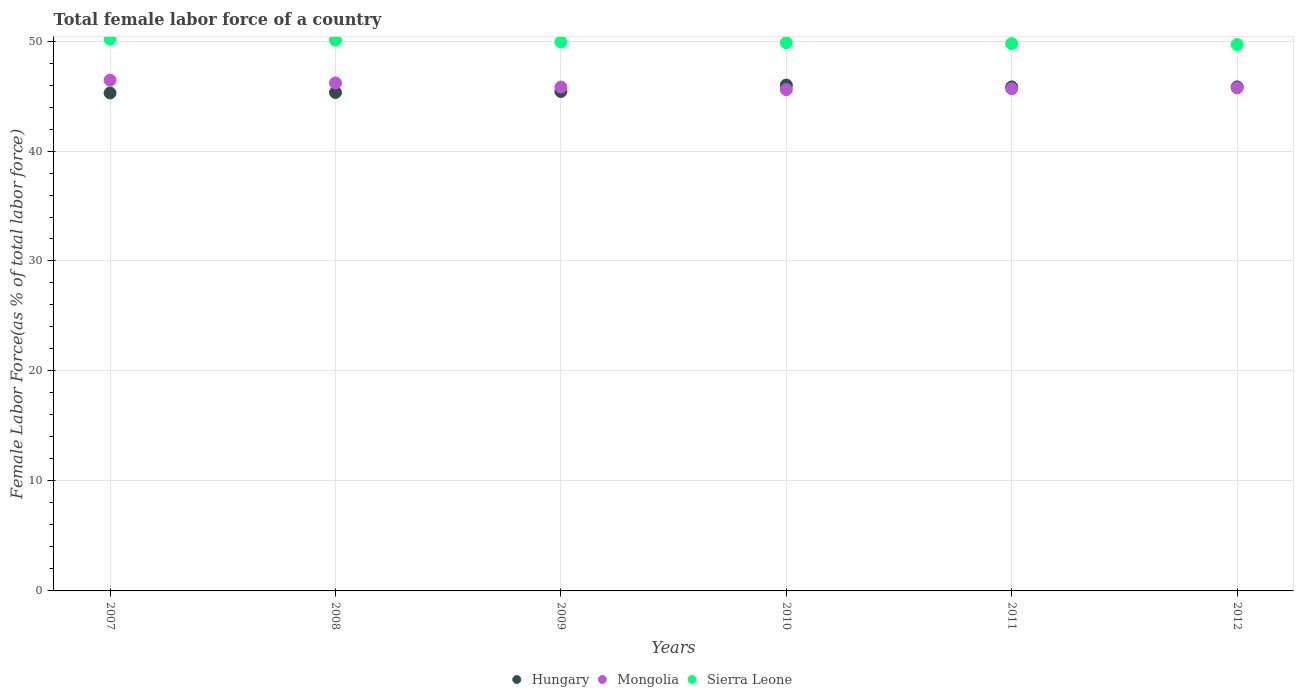How many different coloured dotlines are there?
Offer a very short reply. 3. Is the number of dotlines equal to the number of legend labels?
Provide a succinct answer. Yes. What is the percentage of female labor force in Sierra Leone in 2007?
Offer a very short reply. 50.16. Across all years, what is the maximum percentage of female labor force in Mongolia?
Your answer should be very brief. 46.44. Across all years, what is the minimum percentage of female labor force in Sierra Leone?
Your response must be concise. 49.68. What is the total percentage of female labor force in Hungary in the graph?
Offer a very short reply. 273.67. What is the difference between the percentage of female labor force in Mongolia in 2011 and that in 2012?
Make the answer very short. -0.08. What is the difference between the percentage of female labor force in Hungary in 2008 and the percentage of female labor force in Sierra Leone in 2010?
Provide a succinct answer. -4.52. What is the average percentage of female labor force in Sierra Leone per year?
Your answer should be compact. 49.91. In the year 2010, what is the difference between the percentage of female labor force in Sierra Leone and percentage of female labor force in Hungary?
Your response must be concise. 3.85. What is the ratio of the percentage of female labor force in Sierra Leone in 2011 to that in 2012?
Your answer should be very brief. 1. Is the difference between the percentage of female labor force in Sierra Leone in 2009 and 2012 greater than the difference between the percentage of female labor force in Hungary in 2009 and 2012?
Your response must be concise. Yes. What is the difference between the highest and the second highest percentage of female labor force in Sierra Leone?
Ensure brevity in your answer.  0.08. What is the difference between the highest and the lowest percentage of female labor force in Hungary?
Provide a short and direct response. 0.72. In how many years, is the percentage of female labor force in Sierra Leone greater than the average percentage of female labor force in Sierra Leone taken over all years?
Provide a succinct answer. 3. Is the sum of the percentage of female labor force in Sierra Leone in 2009 and 2010 greater than the maximum percentage of female labor force in Hungary across all years?
Your answer should be compact. Yes. Does the percentage of female labor force in Mongolia monotonically increase over the years?
Your answer should be compact. No. Is the percentage of female labor force in Sierra Leone strictly less than the percentage of female labor force in Hungary over the years?
Provide a succinct answer. No. How many years are there in the graph?
Make the answer very short. 6. Are the values on the major ticks of Y-axis written in scientific E-notation?
Give a very brief answer. No. Does the graph contain any zero values?
Your answer should be very brief. No. How are the legend labels stacked?
Provide a succinct answer. Horizontal. What is the title of the graph?
Provide a succinct answer. Total female labor force of a country. What is the label or title of the X-axis?
Make the answer very short. Years. What is the label or title of the Y-axis?
Provide a succinct answer. Female Labor Force(as % of total labor force). What is the Female Labor Force(as % of total labor force) in Hungary in 2007?
Offer a terse response. 45.28. What is the Female Labor Force(as % of total labor force) of Mongolia in 2007?
Your response must be concise. 46.44. What is the Female Labor Force(as % of total labor force) of Sierra Leone in 2007?
Provide a short and direct response. 50.16. What is the Female Labor Force(as % of total labor force) in Hungary in 2008?
Provide a short and direct response. 45.32. What is the Female Labor Force(as % of total labor force) in Mongolia in 2008?
Keep it short and to the point. 46.18. What is the Female Labor Force(as % of total labor force) in Sierra Leone in 2008?
Ensure brevity in your answer.  50.08. What is the Female Labor Force(as % of total labor force) in Hungary in 2009?
Make the answer very short. 45.41. What is the Female Labor Force(as % of total labor force) of Mongolia in 2009?
Your response must be concise. 45.81. What is the Female Labor Force(as % of total labor force) in Sierra Leone in 2009?
Ensure brevity in your answer.  49.93. What is the Female Labor Force(as % of total labor force) in Hungary in 2010?
Ensure brevity in your answer.  46. What is the Female Labor Force(as % of total labor force) of Mongolia in 2010?
Your answer should be compact. 45.58. What is the Female Labor Force(as % of total labor force) in Sierra Leone in 2010?
Ensure brevity in your answer.  49.85. What is the Female Labor Force(as % of total labor force) in Hungary in 2011?
Ensure brevity in your answer.  45.83. What is the Female Labor Force(as % of total labor force) of Mongolia in 2011?
Offer a terse response. 45.66. What is the Female Labor Force(as % of total labor force) of Sierra Leone in 2011?
Keep it short and to the point. 49.76. What is the Female Labor Force(as % of total labor force) of Hungary in 2012?
Your response must be concise. 45.83. What is the Female Labor Force(as % of total labor force) of Mongolia in 2012?
Your response must be concise. 45.74. What is the Female Labor Force(as % of total labor force) in Sierra Leone in 2012?
Your response must be concise. 49.68. Across all years, what is the maximum Female Labor Force(as % of total labor force) of Hungary?
Make the answer very short. 46. Across all years, what is the maximum Female Labor Force(as % of total labor force) in Mongolia?
Offer a very short reply. 46.44. Across all years, what is the maximum Female Labor Force(as % of total labor force) of Sierra Leone?
Offer a very short reply. 50.16. Across all years, what is the minimum Female Labor Force(as % of total labor force) in Hungary?
Provide a short and direct response. 45.28. Across all years, what is the minimum Female Labor Force(as % of total labor force) of Mongolia?
Provide a short and direct response. 45.58. Across all years, what is the minimum Female Labor Force(as % of total labor force) in Sierra Leone?
Your response must be concise. 49.68. What is the total Female Labor Force(as % of total labor force) in Hungary in the graph?
Keep it short and to the point. 273.67. What is the total Female Labor Force(as % of total labor force) of Mongolia in the graph?
Provide a succinct answer. 275.42. What is the total Female Labor Force(as % of total labor force) of Sierra Leone in the graph?
Keep it short and to the point. 299.46. What is the difference between the Female Labor Force(as % of total labor force) of Hungary in 2007 and that in 2008?
Offer a terse response. -0.04. What is the difference between the Female Labor Force(as % of total labor force) in Mongolia in 2007 and that in 2008?
Your response must be concise. 0.26. What is the difference between the Female Labor Force(as % of total labor force) of Sierra Leone in 2007 and that in 2008?
Make the answer very short. 0.08. What is the difference between the Female Labor Force(as % of total labor force) in Hungary in 2007 and that in 2009?
Provide a succinct answer. -0.13. What is the difference between the Female Labor Force(as % of total labor force) in Mongolia in 2007 and that in 2009?
Your answer should be very brief. 0.63. What is the difference between the Female Labor Force(as % of total labor force) of Sierra Leone in 2007 and that in 2009?
Your answer should be compact. 0.24. What is the difference between the Female Labor Force(as % of total labor force) of Hungary in 2007 and that in 2010?
Your answer should be compact. -0.72. What is the difference between the Female Labor Force(as % of total labor force) in Mongolia in 2007 and that in 2010?
Offer a terse response. 0.86. What is the difference between the Female Labor Force(as % of total labor force) of Sierra Leone in 2007 and that in 2010?
Your response must be concise. 0.32. What is the difference between the Female Labor Force(as % of total labor force) in Hungary in 2007 and that in 2011?
Offer a terse response. -0.55. What is the difference between the Female Labor Force(as % of total labor force) of Mongolia in 2007 and that in 2011?
Offer a very short reply. 0.78. What is the difference between the Female Labor Force(as % of total labor force) of Sierra Leone in 2007 and that in 2011?
Keep it short and to the point. 0.4. What is the difference between the Female Labor Force(as % of total labor force) of Hungary in 2007 and that in 2012?
Offer a very short reply. -0.55. What is the difference between the Female Labor Force(as % of total labor force) of Mongolia in 2007 and that in 2012?
Ensure brevity in your answer.  0.7. What is the difference between the Female Labor Force(as % of total labor force) in Sierra Leone in 2007 and that in 2012?
Provide a succinct answer. 0.48. What is the difference between the Female Labor Force(as % of total labor force) of Hungary in 2008 and that in 2009?
Your answer should be compact. -0.09. What is the difference between the Female Labor Force(as % of total labor force) in Mongolia in 2008 and that in 2009?
Provide a succinct answer. 0.37. What is the difference between the Female Labor Force(as % of total labor force) of Sierra Leone in 2008 and that in 2009?
Provide a short and direct response. 0.16. What is the difference between the Female Labor Force(as % of total labor force) of Hungary in 2008 and that in 2010?
Ensure brevity in your answer.  -0.67. What is the difference between the Female Labor Force(as % of total labor force) of Mongolia in 2008 and that in 2010?
Provide a short and direct response. 0.6. What is the difference between the Female Labor Force(as % of total labor force) of Sierra Leone in 2008 and that in 2010?
Offer a terse response. 0.24. What is the difference between the Female Labor Force(as % of total labor force) in Hungary in 2008 and that in 2011?
Provide a short and direct response. -0.5. What is the difference between the Female Labor Force(as % of total labor force) of Mongolia in 2008 and that in 2011?
Provide a succinct answer. 0.52. What is the difference between the Female Labor Force(as % of total labor force) of Sierra Leone in 2008 and that in 2011?
Your response must be concise. 0.32. What is the difference between the Female Labor Force(as % of total labor force) of Hungary in 2008 and that in 2012?
Offer a terse response. -0.51. What is the difference between the Female Labor Force(as % of total labor force) in Mongolia in 2008 and that in 2012?
Offer a terse response. 0.44. What is the difference between the Female Labor Force(as % of total labor force) in Sierra Leone in 2008 and that in 2012?
Provide a succinct answer. 0.4. What is the difference between the Female Labor Force(as % of total labor force) in Hungary in 2009 and that in 2010?
Your answer should be very brief. -0.59. What is the difference between the Female Labor Force(as % of total labor force) in Mongolia in 2009 and that in 2010?
Make the answer very short. 0.23. What is the difference between the Female Labor Force(as % of total labor force) in Hungary in 2009 and that in 2011?
Offer a very short reply. -0.41. What is the difference between the Female Labor Force(as % of total labor force) in Mongolia in 2009 and that in 2011?
Give a very brief answer. 0.15. What is the difference between the Female Labor Force(as % of total labor force) of Sierra Leone in 2009 and that in 2011?
Offer a very short reply. 0.16. What is the difference between the Female Labor Force(as % of total labor force) of Hungary in 2009 and that in 2012?
Your answer should be compact. -0.42. What is the difference between the Female Labor Force(as % of total labor force) of Mongolia in 2009 and that in 2012?
Offer a terse response. 0.07. What is the difference between the Female Labor Force(as % of total labor force) of Sierra Leone in 2009 and that in 2012?
Ensure brevity in your answer.  0.25. What is the difference between the Female Labor Force(as % of total labor force) of Hungary in 2010 and that in 2011?
Offer a very short reply. 0.17. What is the difference between the Female Labor Force(as % of total labor force) of Mongolia in 2010 and that in 2011?
Give a very brief answer. -0.08. What is the difference between the Female Labor Force(as % of total labor force) of Sierra Leone in 2010 and that in 2011?
Ensure brevity in your answer.  0.08. What is the difference between the Female Labor Force(as % of total labor force) in Hungary in 2010 and that in 2012?
Keep it short and to the point. 0.17. What is the difference between the Female Labor Force(as % of total labor force) in Mongolia in 2010 and that in 2012?
Ensure brevity in your answer.  -0.16. What is the difference between the Female Labor Force(as % of total labor force) in Sierra Leone in 2010 and that in 2012?
Make the answer very short. 0.17. What is the difference between the Female Labor Force(as % of total labor force) in Hungary in 2011 and that in 2012?
Your response must be concise. -0. What is the difference between the Female Labor Force(as % of total labor force) in Mongolia in 2011 and that in 2012?
Provide a short and direct response. -0.08. What is the difference between the Female Labor Force(as % of total labor force) of Sierra Leone in 2011 and that in 2012?
Keep it short and to the point. 0.08. What is the difference between the Female Labor Force(as % of total labor force) in Hungary in 2007 and the Female Labor Force(as % of total labor force) in Mongolia in 2008?
Give a very brief answer. -0.9. What is the difference between the Female Labor Force(as % of total labor force) in Hungary in 2007 and the Female Labor Force(as % of total labor force) in Sierra Leone in 2008?
Make the answer very short. -4.8. What is the difference between the Female Labor Force(as % of total labor force) in Mongolia in 2007 and the Female Labor Force(as % of total labor force) in Sierra Leone in 2008?
Provide a succinct answer. -3.64. What is the difference between the Female Labor Force(as % of total labor force) in Hungary in 2007 and the Female Labor Force(as % of total labor force) in Mongolia in 2009?
Ensure brevity in your answer.  -0.53. What is the difference between the Female Labor Force(as % of total labor force) of Hungary in 2007 and the Female Labor Force(as % of total labor force) of Sierra Leone in 2009?
Your answer should be very brief. -4.65. What is the difference between the Female Labor Force(as % of total labor force) of Mongolia in 2007 and the Female Labor Force(as % of total labor force) of Sierra Leone in 2009?
Your answer should be compact. -3.49. What is the difference between the Female Labor Force(as % of total labor force) in Hungary in 2007 and the Female Labor Force(as % of total labor force) in Mongolia in 2010?
Your answer should be compact. -0.31. What is the difference between the Female Labor Force(as % of total labor force) of Hungary in 2007 and the Female Labor Force(as % of total labor force) of Sierra Leone in 2010?
Ensure brevity in your answer.  -4.57. What is the difference between the Female Labor Force(as % of total labor force) in Mongolia in 2007 and the Female Labor Force(as % of total labor force) in Sierra Leone in 2010?
Your answer should be very brief. -3.41. What is the difference between the Female Labor Force(as % of total labor force) in Hungary in 2007 and the Female Labor Force(as % of total labor force) in Mongolia in 2011?
Keep it short and to the point. -0.38. What is the difference between the Female Labor Force(as % of total labor force) of Hungary in 2007 and the Female Labor Force(as % of total labor force) of Sierra Leone in 2011?
Ensure brevity in your answer.  -4.48. What is the difference between the Female Labor Force(as % of total labor force) of Mongolia in 2007 and the Female Labor Force(as % of total labor force) of Sierra Leone in 2011?
Provide a short and direct response. -3.32. What is the difference between the Female Labor Force(as % of total labor force) in Hungary in 2007 and the Female Labor Force(as % of total labor force) in Mongolia in 2012?
Offer a terse response. -0.46. What is the difference between the Female Labor Force(as % of total labor force) of Hungary in 2007 and the Female Labor Force(as % of total labor force) of Sierra Leone in 2012?
Offer a very short reply. -4.4. What is the difference between the Female Labor Force(as % of total labor force) of Mongolia in 2007 and the Female Labor Force(as % of total labor force) of Sierra Leone in 2012?
Keep it short and to the point. -3.24. What is the difference between the Female Labor Force(as % of total labor force) in Hungary in 2008 and the Female Labor Force(as % of total labor force) in Mongolia in 2009?
Provide a short and direct response. -0.49. What is the difference between the Female Labor Force(as % of total labor force) in Hungary in 2008 and the Female Labor Force(as % of total labor force) in Sierra Leone in 2009?
Offer a very short reply. -4.6. What is the difference between the Female Labor Force(as % of total labor force) in Mongolia in 2008 and the Female Labor Force(as % of total labor force) in Sierra Leone in 2009?
Make the answer very short. -3.74. What is the difference between the Female Labor Force(as % of total labor force) of Hungary in 2008 and the Female Labor Force(as % of total labor force) of Mongolia in 2010?
Offer a terse response. -0.26. What is the difference between the Female Labor Force(as % of total labor force) in Hungary in 2008 and the Female Labor Force(as % of total labor force) in Sierra Leone in 2010?
Offer a terse response. -4.52. What is the difference between the Female Labor Force(as % of total labor force) of Mongolia in 2008 and the Female Labor Force(as % of total labor force) of Sierra Leone in 2010?
Ensure brevity in your answer.  -3.66. What is the difference between the Female Labor Force(as % of total labor force) in Hungary in 2008 and the Female Labor Force(as % of total labor force) in Mongolia in 2011?
Offer a very short reply. -0.34. What is the difference between the Female Labor Force(as % of total labor force) of Hungary in 2008 and the Female Labor Force(as % of total labor force) of Sierra Leone in 2011?
Your response must be concise. -4.44. What is the difference between the Female Labor Force(as % of total labor force) of Mongolia in 2008 and the Female Labor Force(as % of total labor force) of Sierra Leone in 2011?
Offer a terse response. -3.58. What is the difference between the Female Labor Force(as % of total labor force) in Hungary in 2008 and the Female Labor Force(as % of total labor force) in Mongolia in 2012?
Your answer should be compact. -0.42. What is the difference between the Female Labor Force(as % of total labor force) in Hungary in 2008 and the Female Labor Force(as % of total labor force) in Sierra Leone in 2012?
Make the answer very short. -4.36. What is the difference between the Female Labor Force(as % of total labor force) of Mongolia in 2008 and the Female Labor Force(as % of total labor force) of Sierra Leone in 2012?
Offer a terse response. -3.5. What is the difference between the Female Labor Force(as % of total labor force) in Hungary in 2009 and the Female Labor Force(as % of total labor force) in Mongolia in 2010?
Give a very brief answer. -0.17. What is the difference between the Female Labor Force(as % of total labor force) in Hungary in 2009 and the Female Labor Force(as % of total labor force) in Sierra Leone in 2010?
Make the answer very short. -4.44. What is the difference between the Female Labor Force(as % of total labor force) in Mongolia in 2009 and the Female Labor Force(as % of total labor force) in Sierra Leone in 2010?
Make the answer very short. -4.04. What is the difference between the Female Labor Force(as % of total labor force) of Hungary in 2009 and the Female Labor Force(as % of total labor force) of Mongolia in 2011?
Offer a very short reply. -0.25. What is the difference between the Female Labor Force(as % of total labor force) in Hungary in 2009 and the Female Labor Force(as % of total labor force) in Sierra Leone in 2011?
Offer a terse response. -4.35. What is the difference between the Female Labor Force(as % of total labor force) of Mongolia in 2009 and the Female Labor Force(as % of total labor force) of Sierra Leone in 2011?
Your answer should be very brief. -3.95. What is the difference between the Female Labor Force(as % of total labor force) in Hungary in 2009 and the Female Labor Force(as % of total labor force) in Mongolia in 2012?
Make the answer very short. -0.33. What is the difference between the Female Labor Force(as % of total labor force) in Hungary in 2009 and the Female Labor Force(as % of total labor force) in Sierra Leone in 2012?
Make the answer very short. -4.27. What is the difference between the Female Labor Force(as % of total labor force) in Mongolia in 2009 and the Female Labor Force(as % of total labor force) in Sierra Leone in 2012?
Your response must be concise. -3.87. What is the difference between the Female Labor Force(as % of total labor force) of Hungary in 2010 and the Female Labor Force(as % of total labor force) of Mongolia in 2011?
Your response must be concise. 0.33. What is the difference between the Female Labor Force(as % of total labor force) of Hungary in 2010 and the Female Labor Force(as % of total labor force) of Sierra Leone in 2011?
Your answer should be compact. -3.77. What is the difference between the Female Labor Force(as % of total labor force) of Mongolia in 2010 and the Female Labor Force(as % of total labor force) of Sierra Leone in 2011?
Keep it short and to the point. -4.18. What is the difference between the Female Labor Force(as % of total labor force) of Hungary in 2010 and the Female Labor Force(as % of total labor force) of Mongolia in 2012?
Provide a succinct answer. 0.26. What is the difference between the Female Labor Force(as % of total labor force) of Hungary in 2010 and the Female Labor Force(as % of total labor force) of Sierra Leone in 2012?
Make the answer very short. -3.68. What is the difference between the Female Labor Force(as % of total labor force) of Mongolia in 2010 and the Female Labor Force(as % of total labor force) of Sierra Leone in 2012?
Offer a very short reply. -4.1. What is the difference between the Female Labor Force(as % of total labor force) in Hungary in 2011 and the Female Labor Force(as % of total labor force) in Mongolia in 2012?
Offer a terse response. 0.09. What is the difference between the Female Labor Force(as % of total labor force) of Hungary in 2011 and the Female Labor Force(as % of total labor force) of Sierra Leone in 2012?
Provide a succinct answer. -3.85. What is the difference between the Female Labor Force(as % of total labor force) in Mongolia in 2011 and the Female Labor Force(as % of total labor force) in Sierra Leone in 2012?
Your answer should be compact. -4.02. What is the average Female Labor Force(as % of total labor force) of Hungary per year?
Offer a terse response. 45.61. What is the average Female Labor Force(as % of total labor force) in Mongolia per year?
Provide a succinct answer. 45.9. What is the average Female Labor Force(as % of total labor force) in Sierra Leone per year?
Your response must be concise. 49.91. In the year 2007, what is the difference between the Female Labor Force(as % of total labor force) of Hungary and Female Labor Force(as % of total labor force) of Mongolia?
Offer a terse response. -1.16. In the year 2007, what is the difference between the Female Labor Force(as % of total labor force) of Hungary and Female Labor Force(as % of total labor force) of Sierra Leone?
Make the answer very short. -4.88. In the year 2007, what is the difference between the Female Labor Force(as % of total labor force) of Mongolia and Female Labor Force(as % of total labor force) of Sierra Leone?
Provide a succinct answer. -3.72. In the year 2008, what is the difference between the Female Labor Force(as % of total labor force) of Hungary and Female Labor Force(as % of total labor force) of Mongolia?
Ensure brevity in your answer.  -0.86. In the year 2008, what is the difference between the Female Labor Force(as % of total labor force) of Hungary and Female Labor Force(as % of total labor force) of Sierra Leone?
Your response must be concise. -4.76. In the year 2008, what is the difference between the Female Labor Force(as % of total labor force) of Mongolia and Female Labor Force(as % of total labor force) of Sierra Leone?
Provide a succinct answer. -3.9. In the year 2009, what is the difference between the Female Labor Force(as % of total labor force) of Hungary and Female Labor Force(as % of total labor force) of Mongolia?
Your answer should be compact. -0.4. In the year 2009, what is the difference between the Female Labor Force(as % of total labor force) of Hungary and Female Labor Force(as % of total labor force) of Sierra Leone?
Your answer should be compact. -4.52. In the year 2009, what is the difference between the Female Labor Force(as % of total labor force) in Mongolia and Female Labor Force(as % of total labor force) in Sierra Leone?
Ensure brevity in your answer.  -4.12. In the year 2010, what is the difference between the Female Labor Force(as % of total labor force) in Hungary and Female Labor Force(as % of total labor force) in Mongolia?
Offer a very short reply. 0.41. In the year 2010, what is the difference between the Female Labor Force(as % of total labor force) in Hungary and Female Labor Force(as % of total labor force) in Sierra Leone?
Provide a succinct answer. -3.85. In the year 2010, what is the difference between the Female Labor Force(as % of total labor force) in Mongolia and Female Labor Force(as % of total labor force) in Sierra Leone?
Ensure brevity in your answer.  -4.26. In the year 2011, what is the difference between the Female Labor Force(as % of total labor force) of Hungary and Female Labor Force(as % of total labor force) of Mongolia?
Give a very brief answer. 0.16. In the year 2011, what is the difference between the Female Labor Force(as % of total labor force) of Hungary and Female Labor Force(as % of total labor force) of Sierra Leone?
Your answer should be compact. -3.94. In the year 2011, what is the difference between the Female Labor Force(as % of total labor force) of Mongolia and Female Labor Force(as % of total labor force) of Sierra Leone?
Offer a terse response. -4.1. In the year 2012, what is the difference between the Female Labor Force(as % of total labor force) in Hungary and Female Labor Force(as % of total labor force) in Mongolia?
Provide a short and direct response. 0.09. In the year 2012, what is the difference between the Female Labor Force(as % of total labor force) in Hungary and Female Labor Force(as % of total labor force) in Sierra Leone?
Give a very brief answer. -3.85. In the year 2012, what is the difference between the Female Labor Force(as % of total labor force) in Mongolia and Female Labor Force(as % of total labor force) in Sierra Leone?
Give a very brief answer. -3.94. What is the ratio of the Female Labor Force(as % of total labor force) in Mongolia in 2007 to that in 2008?
Offer a terse response. 1.01. What is the ratio of the Female Labor Force(as % of total labor force) in Sierra Leone in 2007 to that in 2008?
Your response must be concise. 1. What is the ratio of the Female Labor Force(as % of total labor force) of Hungary in 2007 to that in 2009?
Your answer should be compact. 1. What is the ratio of the Female Labor Force(as % of total labor force) in Mongolia in 2007 to that in 2009?
Offer a very short reply. 1.01. What is the ratio of the Female Labor Force(as % of total labor force) of Sierra Leone in 2007 to that in 2009?
Ensure brevity in your answer.  1. What is the ratio of the Female Labor Force(as % of total labor force) of Hungary in 2007 to that in 2010?
Offer a very short reply. 0.98. What is the ratio of the Female Labor Force(as % of total labor force) of Mongolia in 2007 to that in 2010?
Offer a terse response. 1.02. What is the ratio of the Female Labor Force(as % of total labor force) of Sierra Leone in 2007 to that in 2010?
Your response must be concise. 1.01. What is the ratio of the Female Labor Force(as % of total labor force) of Hungary in 2007 to that in 2011?
Your answer should be very brief. 0.99. What is the ratio of the Female Labor Force(as % of total labor force) of Mongolia in 2007 to that in 2011?
Your response must be concise. 1.02. What is the ratio of the Female Labor Force(as % of total labor force) in Mongolia in 2007 to that in 2012?
Give a very brief answer. 1.02. What is the ratio of the Female Labor Force(as % of total labor force) of Sierra Leone in 2007 to that in 2012?
Offer a terse response. 1.01. What is the ratio of the Female Labor Force(as % of total labor force) of Mongolia in 2008 to that in 2009?
Your answer should be very brief. 1.01. What is the ratio of the Female Labor Force(as % of total labor force) of Sierra Leone in 2008 to that in 2009?
Your answer should be very brief. 1. What is the ratio of the Female Labor Force(as % of total labor force) of Mongolia in 2008 to that in 2010?
Your answer should be very brief. 1.01. What is the ratio of the Female Labor Force(as % of total labor force) of Sierra Leone in 2008 to that in 2010?
Your answer should be very brief. 1. What is the ratio of the Female Labor Force(as % of total labor force) of Hungary in 2008 to that in 2011?
Provide a succinct answer. 0.99. What is the ratio of the Female Labor Force(as % of total labor force) of Mongolia in 2008 to that in 2011?
Your answer should be compact. 1.01. What is the ratio of the Female Labor Force(as % of total labor force) of Sierra Leone in 2008 to that in 2011?
Your answer should be compact. 1.01. What is the ratio of the Female Labor Force(as % of total labor force) in Hungary in 2008 to that in 2012?
Ensure brevity in your answer.  0.99. What is the ratio of the Female Labor Force(as % of total labor force) of Mongolia in 2008 to that in 2012?
Make the answer very short. 1.01. What is the ratio of the Female Labor Force(as % of total labor force) of Hungary in 2009 to that in 2010?
Offer a terse response. 0.99. What is the ratio of the Female Labor Force(as % of total labor force) of Sierra Leone in 2009 to that in 2010?
Your response must be concise. 1. What is the ratio of the Female Labor Force(as % of total labor force) of Hungary in 2009 to that in 2011?
Your answer should be very brief. 0.99. What is the ratio of the Female Labor Force(as % of total labor force) in Mongolia in 2009 to that in 2011?
Your answer should be compact. 1. What is the ratio of the Female Labor Force(as % of total labor force) in Hungary in 2009 to that in 2012?
Your answer should be very brief. 0.99. What is the ratio of the Female Labor Force(as % of total labor force) of Hungary in 2010 to that in 2011?
Offer a very short reply. 1. What is the ratio of the Female Labor Force(as % of total labor force) of Mongolia in 2010 to that in 2011?
Offer a very short reply. 1. What is the ratio of the Female Labor Force(as % of total labor force) in Sierra Leone in 2010 to that in 2011?
Your answer should be compact. 1. What is the ratio of the Female Labor Force(as % of total labor force) in Hungary in 2010 to that in 2012?
Offer a terse response. 1. What is the ratio of the Female Labor Force(as % of total labor force) of Hungary in 2011 to that in 2012?
Provide a short and direct response. 1. What is the ratio of the Female Labor Force(as % of total labor force) of Mongolia in 2011 to that in 2012?
Offer a very short reply. 1. What is the ratio of the Female Labor Force(as % of total labor force) of Sierra Leone in 2011 to that in 2012?
Your response must be concise. 1. What is the difference between the highest and the second highest Female Labor Force(as % of total labor force) in Hungary?
Make the answer very short. 0.17. What is the difference between the highest and the second highest Female Labor Force(as % of total labor force) in Mongolia?
Offer a very short reply. 0.26. What is the difference between the highest and the second highest Female Labor Force(as % of total labor force) in Sierra Leone?
Ensure brevity in your answer.  0.08. What is the difference between the highest and the lowest Female Labor Force(as % of total labor force) in Hungary?
Your answer should be very brief. 0.72. What is the difference between the highest and the lowest Female Labor Force(as % of total labor force) in Mongolia?
Provide a succinct answer. 0.86. What is the difference between the highest and the lowest Female Labor Force(as % of total labor force) of Sierra Leone?
Provide a short and direct response. 0.48. 